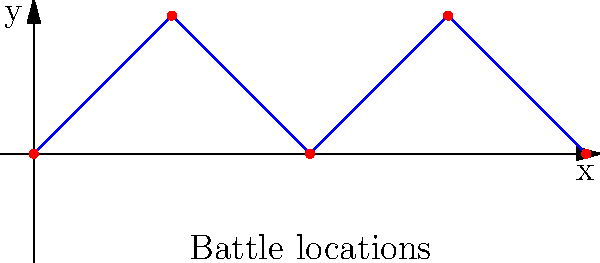As a journalist documenting the general's stories, you've mapped out the interconnected battle locations forming a surface. Given that these locations are connected sequentially as shown in the diagram, what is the genus of the resulting surface? Assume the surface is closed by connecting the first and last points. To determine the genus of the surface formed by the interconnected battle locations, we need to follow these steps:

1. Identify the shape: The battle locations form a closed loop when we connect the first and last points.

2. Analyze the crossings: In this case, there are no self-intersections in the path.

3. Determine the resulting surface: When we consider this as a closed loop without self-intersections, it forms a simple closed curve.

4. Apply the Jordan Curve Theorem: This theorem states that a simple closed curve in a plane divides the plane into two regions: an "inside" and an "outside".

5. Interpret the surface: If we consider this curve as the boundary of a surface, it forms a disc-like shape.

6. Calculate the genus: The genus of a surface is the number of "holes" or "handles" it has. A disc-like shape has no holes.

7. Conclude: The resulting surface is topologically equivalent to a sphere, which has a genus of 0.

Therefore, the genus of the surface formed by these interconnected battle locations is 0.
Answer: 0 